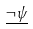Convert formula to latex. <formula><loc_0><loc_0><loc_500><loc_500>\underline { \neg \psi }</formula> 